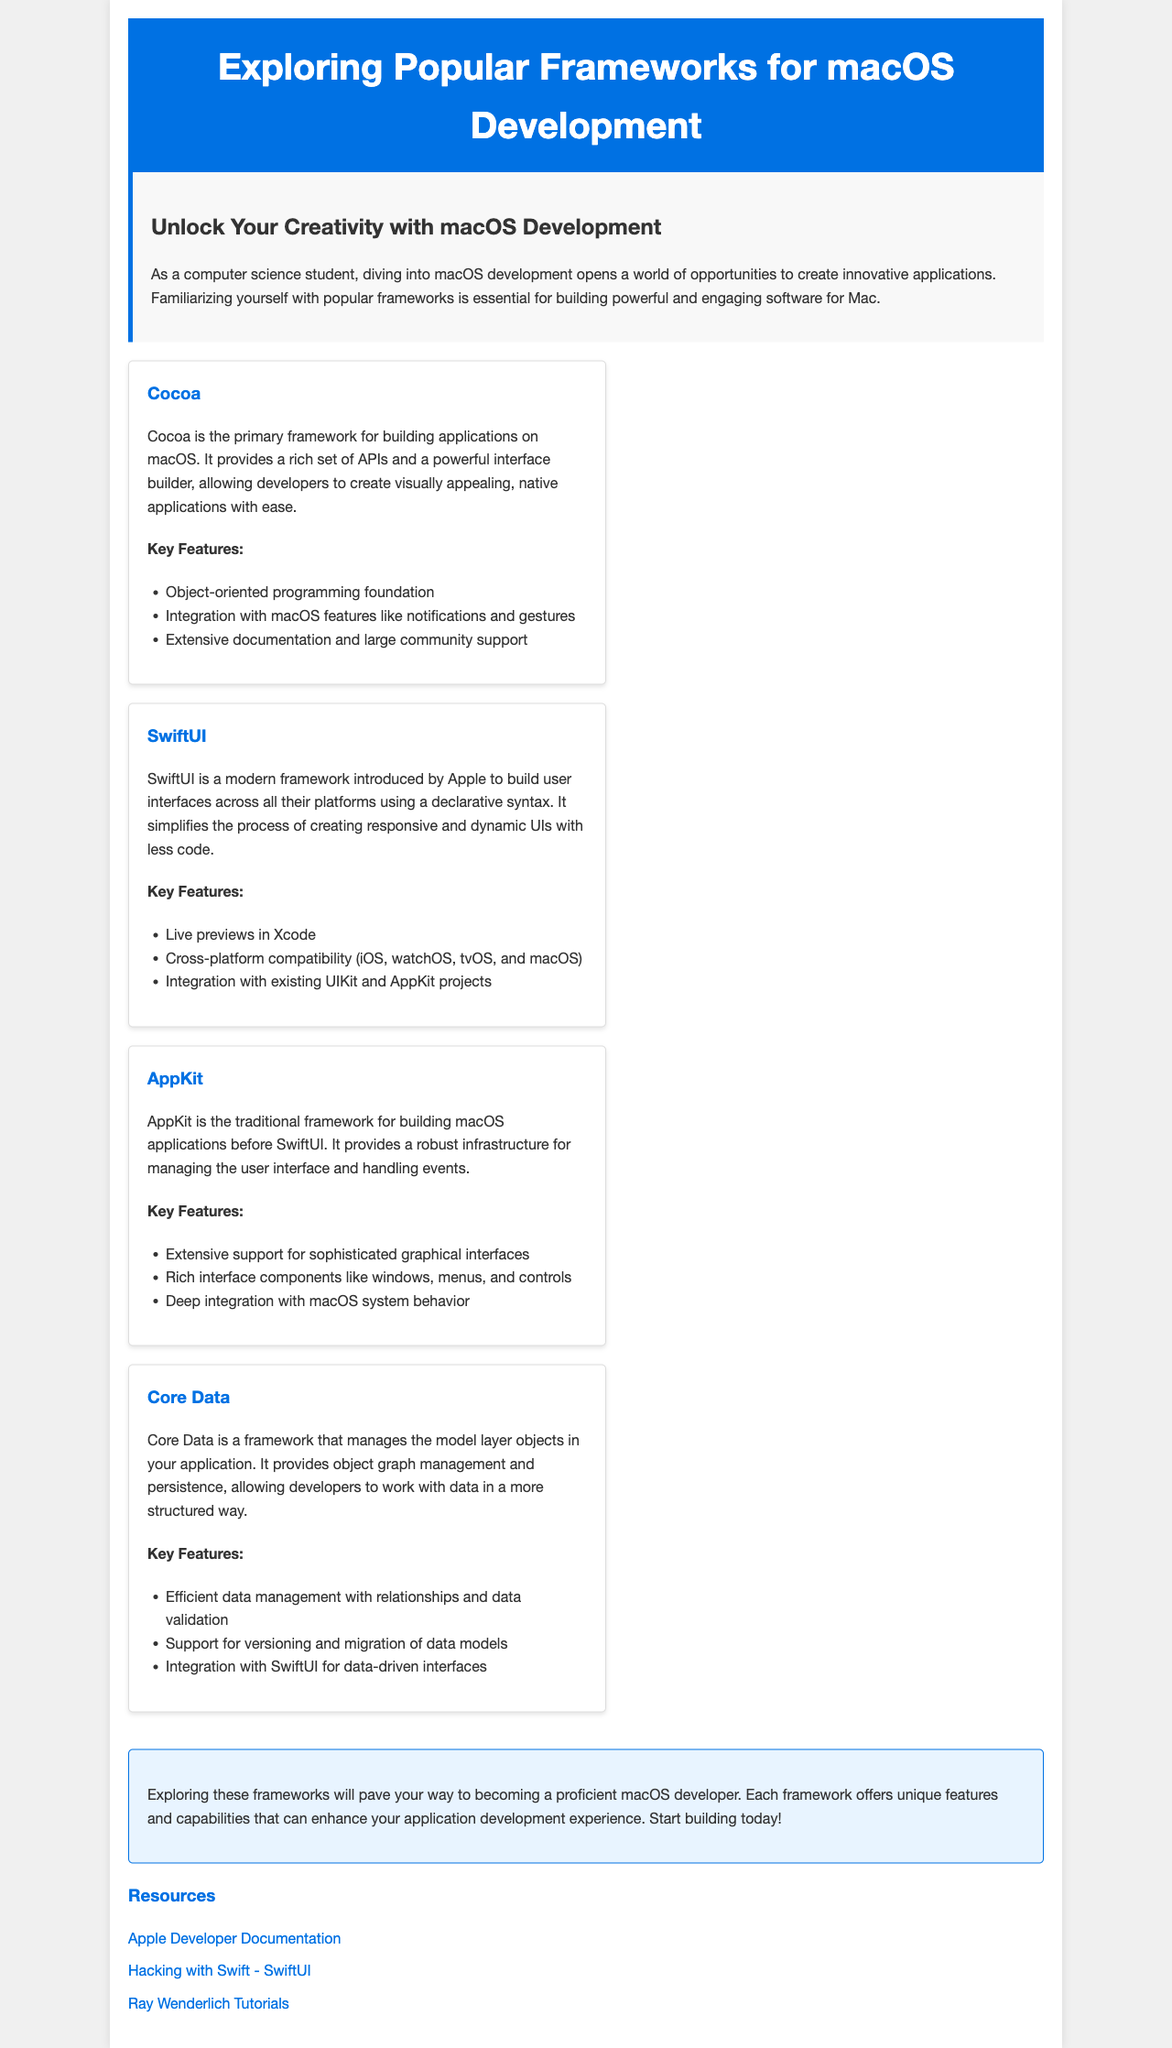What is the title of the brochure? The title is the main heading at the top of the document, stating the subject of the content.
Answer: Exploring Popular Frameworks for macOS Development What framework is primarily used for building applications on macOS? This is specified in the section that discusses Cocoa, highlighting its significance.
Answer: Cocoa Which framework simplifies the process of creating responsive UIs? This refers to the framework that uses a declarative syntax, allowing for easier UI creation.
Answer: SwiftUI How many key features are listed for AppKit? The number of features can be counted from the list provided under the AppKit description.
Answer: Three What color is used for the header background? This refers to the visual color detail mentioned in the header styling of the brochure.
Answer: Blue What is one resource mentioned in the brochure? This looks for a specific example of a resource provided in the resources section.
Answer: Apple Developer Documentation Which framework offers object graph management and persistence? This will relate to the framework that helps manage model layer objects effectively.
Answer: Core Data What type of programming foundation does Cocoa provide? This asks about the fundamental programming style associated with Cocoa.
Answer: Object-oriented programming What does the conclusion encourage readers to start doing? This refers to the action that readers are motivated to take at the end of the brochure.
Answer: Building 